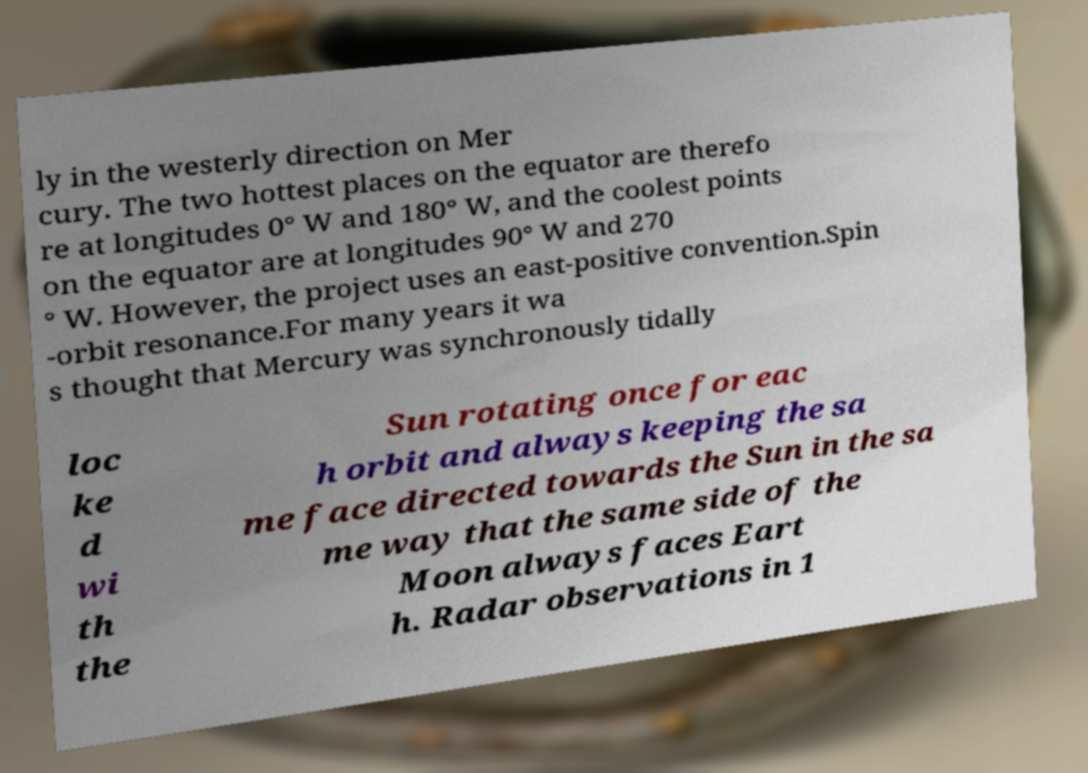Can you read and provide the text displayed in the image?This photo seems to have some interesting text. Can you extract and type it out for me? ly in the westerly direction on Mer cury. The two hottest places on the equator are therefo re at longitudes 0° W and 180° W, and the coolest points on the equator are at longitudes 90° W and 270 ° W. However, the project uses an east-positive convention.Spin -orbit resonance.For many years it wa s thought that Mercury was synchronously tidally loc ke d wi th the Sun rotating once for eac h orbit and always keeping the sa me face directed towards the Sun in the sa me way that the same side of the Moon always faces Eart h. Radar observations in 1 